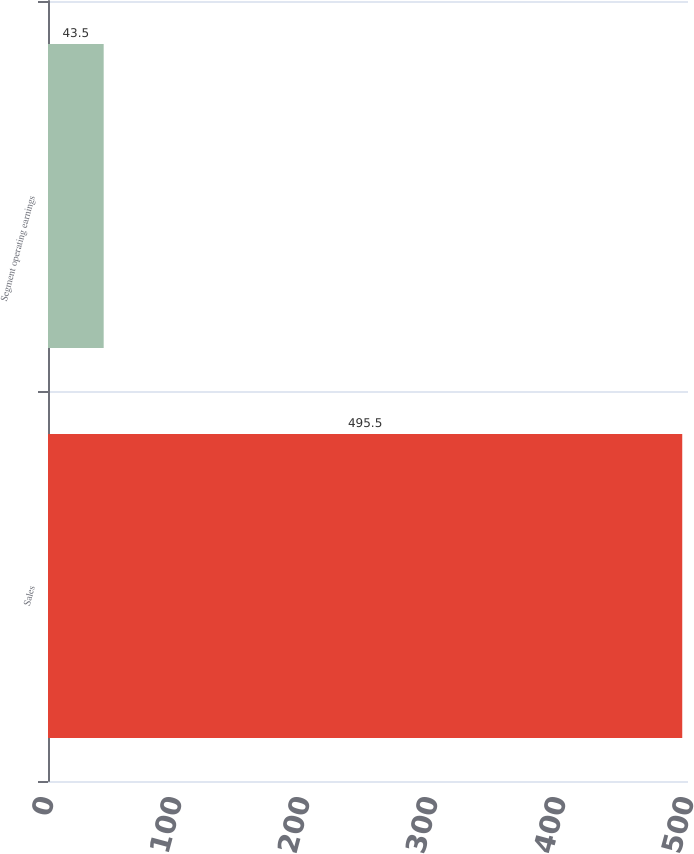Convert chart to OTSL. <chart><loc_0><loc_0><loc_500><loc_500><bar_chart><fcel>Sales<fcel>Segment operating earnings<nl><fcel>495.5<fcel>43.5<nl></chart> 